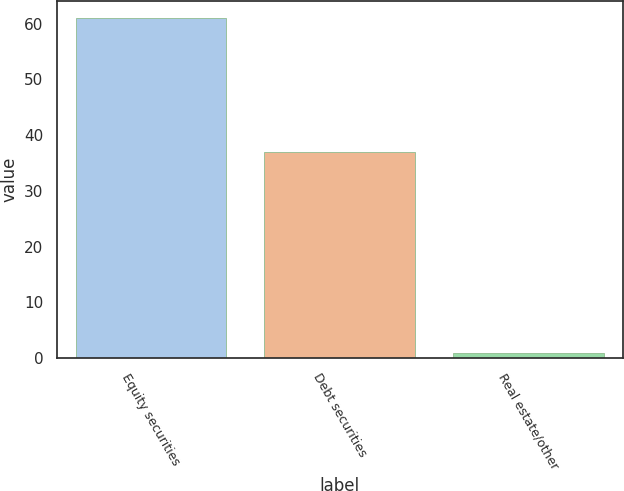Convert chart. <chart><loc_0><loc_0><loc_500><loc_500><bar_chart><fcel>Equity securities<fcel>Debt securities<fcel>Real estate/other<nl><fcel>61<fcel>37<fcel>1<nl></chart> 